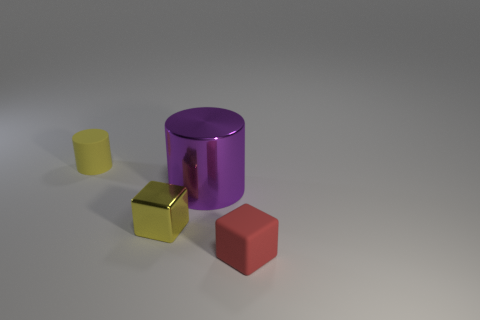Do the purple metal object and the rubber object that is to the left of the big purple metal object have the same shape?
Make the answer very short. Yes. The tiny object left of the cube left of the block that is in front of the tiny shiny object is made of what material?
Your response must be concise. Rubber. Are there any other metallic things of the same size as the yellow shiny thing?
Provide a succinct answer. No. The thing that is the same material as the tiny red block is what size?
Provide a succinct answer. Small. What shape is the yellow metal thing?
Provide a short and direct response. Cube. Is the yellow cube made of the same material as the small yellow thing behind the purple shiny cylinder?
Provide a short and direct response. No. How many things are either small yellow rubber things or big yellow matte balls?
Make the answer very short. 1. Are any big green spheres visible?
Your answer should be very brief. No. What is the shape of the tiny rubber object that is behind the rubber object right of the tiny yellow cylinder?
Your answer should be compact. Cylinder. What number of things are either things behind the red matte cube or tiny rubber objects that are to the left of the red matte thing?
Provide a succinct answer. 3. 